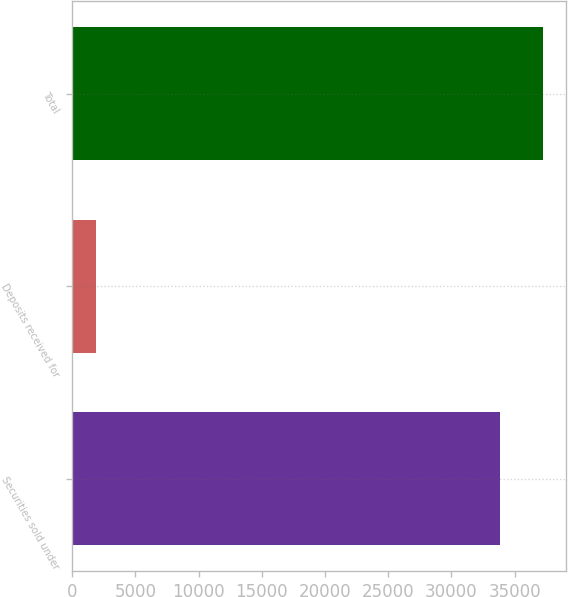<chart> <loc_0><loc_0><loc_500><loc_500><bar_chart><fcel>Securities sold under<fcel>Deposits received for<fcel>Total<nl><fcel>33846<fcel>1912<fcel>37230.6<nl></chart> 